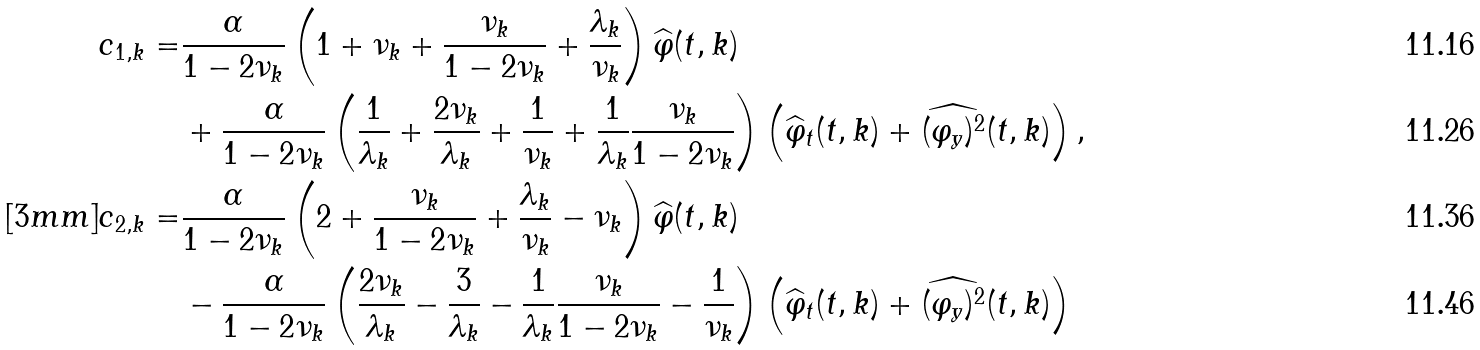<formula> <loc_0><loc_0><loc_500><loc_500>c _ { 1 , k } = & \frac { \alpha } { 1 - 2 \nu _ { k } } \left ( 1 + \nu _ { k } + \frac { \nu _ { k } } { 1 - 2 \nu _ { k } } + \frac { \lambda _ { k } } { \nu _ { k } } \right ) \widehat { \varphi } ( t , k ) \\ & + \frac { \alpha } { 1 - 2 \nu _ { k } } \left ( \frac { 1 } { \lambda _ { k } } + \frac { 2 \nu _ { k } } { \lambda _ { k } } + \frac { 1 } { \nu _ { k } } + \frac { 1 } { \lambda _ { k } } \frac { \nu _ { k } } { 1 - 2 \nu _ { k } } \right ) \left ( \widehat { \varphi } _ { t } ( t , k ) + \widehat { ( \varphi _ { y } ) ^ { 2 } } ( t , k ) \right ) , \\ [ 3 m m ] c _ { 2 , k } = & \frac { \alpha } { 1 - 2 \nu _ { k } } \left ( 2 + \frac { \nu _ { k } } { 1 - 2 \nu _ { k } } + \frac { \lambda _ { k } } { \nu _ { k } } - \nu _ { k } \right ) \widehat { \varphi } ( t , k ) \\ & - \frac { \alpha } { 1 - 2 \nu _ { k } } \left ( \frac { 2 \nu _ { k } } { \lambda _ { k } } - \frac { 3 } { \lambda _ { k } } - \frac { 1 } { \lambda _ { k } } \frac { \nu _ { k } } { 1 - 2 \nu _ { k } } - \frac { 1 } { \nu _ { k } } \right ) \left ( \widehat { \varphi } _ { t } ( t , k ) + \widehat { ( \varphi _ { y } ) ^ { 2 } } ( t , k ) \right )</formula> 